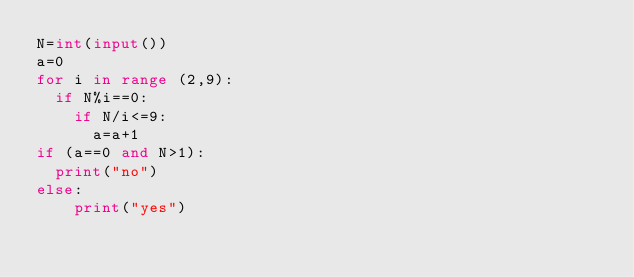<code> <loc_0><loc_0><loc_500><loc_500><_Python_>N=int(input())
a=0
for i in range (2,9):
  if N%i==0:
    if N/i<=9:
      a=a+1
if (a==0 and N>1):
  print("no")
else:
    print("yes")
    </code> 